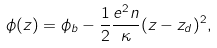<formula> <loc_0><loc_0><loc_500><loc_500>\phi ( z ) = \phi _ { b } - \frac { 1 } { 2 } \frac { e ^ { 2 } n } { \kappa } ( z - z _ { d } ) ^ { 2 } ,</formula> 